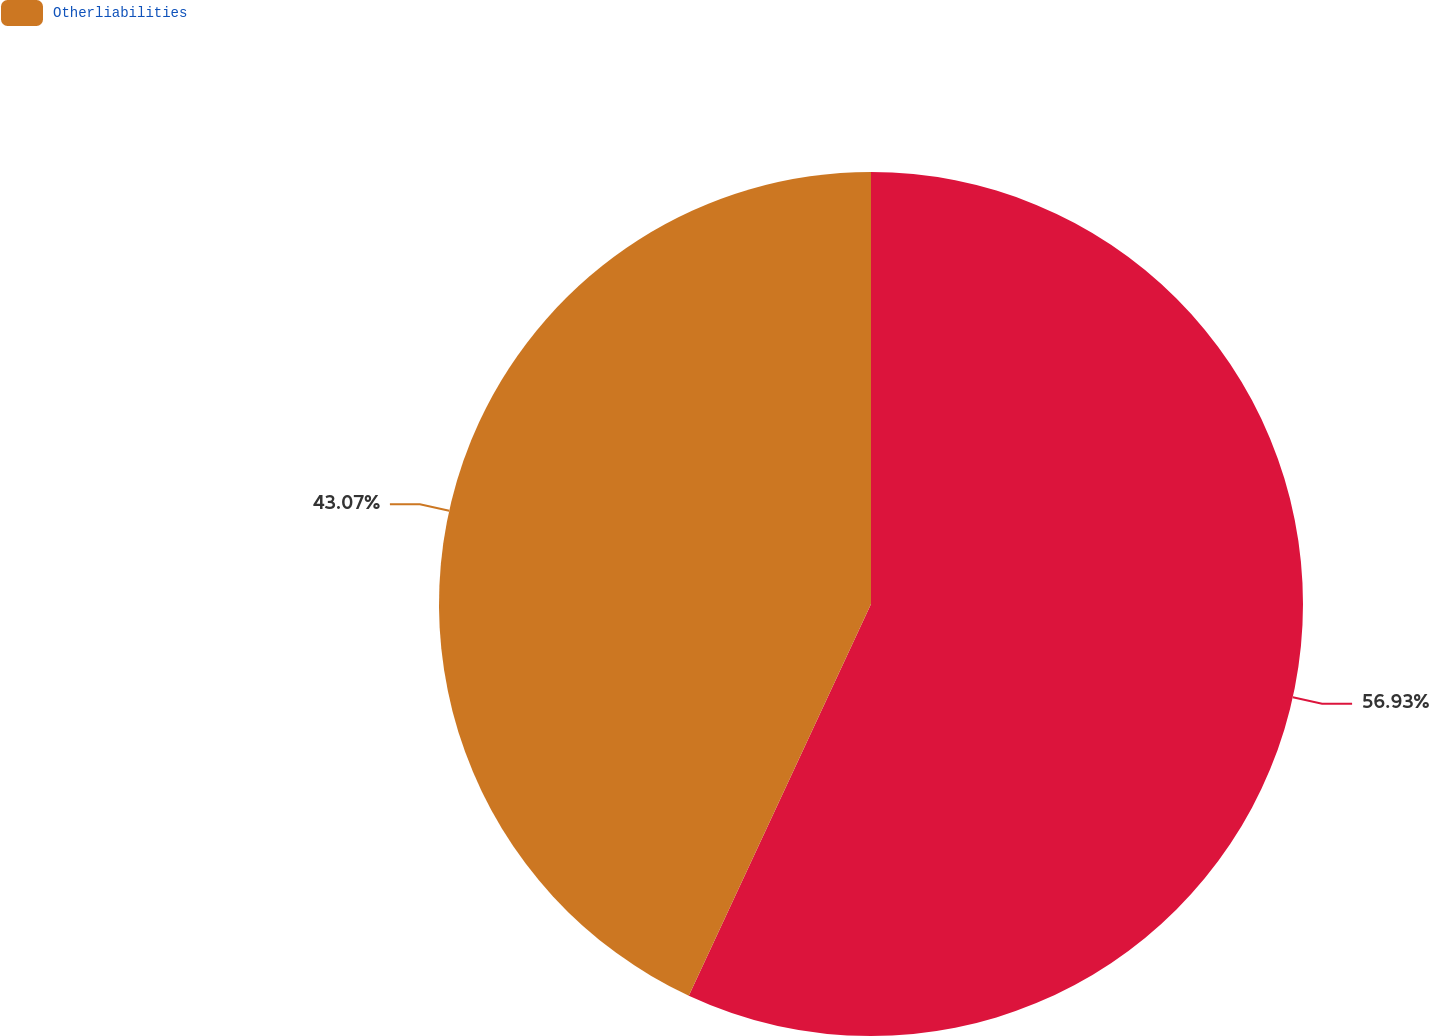<chart> <loc_0><loc_0><loc_500><loc_500><pie_chart><ecel><fcel>Otherliabilities<nl><fcel>56.93%<fcel>43.07%<nl></chart> 